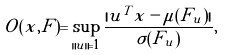Convert formula to latex. <formula><loc_0><loc_0><loc_500><loc_500>O ( x , F ) = \sup _ { \| u \| = 1 } \frac { | u ^ { T } x - \mu ( F _ { u } ) | } { \sigma ( F _ { u } ) } ,</formula> 